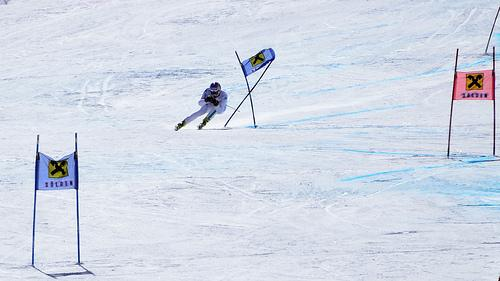Describe the skiing outfit and the person's protective gear. The skier is wearing a white outfit and has a helmet made of plastic on their head. Describe the environment and some objects in it. The environment is covered in snow, with snow all over the ground, a red sign with lettering, and a pink flag stuck on the poles. What kind of obstacle is the skier navigating around? The skier is navigating around a blue flag held up by bent poles on the snow. What is the skier's stance, and what kind of equipment are they using? The skier is at an angle, wearing a helmet, and using skiis on their feet. Describe any noticeable features or markings on the flag. There is a logo on the flag. What is the main activity happening in this image? A person is skiing down the hill while rounding a blue flag on snow. How is the main subject's position in relation to the blue flag? The main subject is a skier who is closest to the blue flag while rounding it on the snow. Mention a detail about the sign in the snow. The sign in the snow is red in color and has lettering on it. Where is the flag and what color is it? The flag is near the skier, held up by bent poles, and it is blue in color. Choose three objects from the image and briefly describe their features. A pink boundary flag in the snow, ski tracks in the snow, and light blue lines all over the snow. 